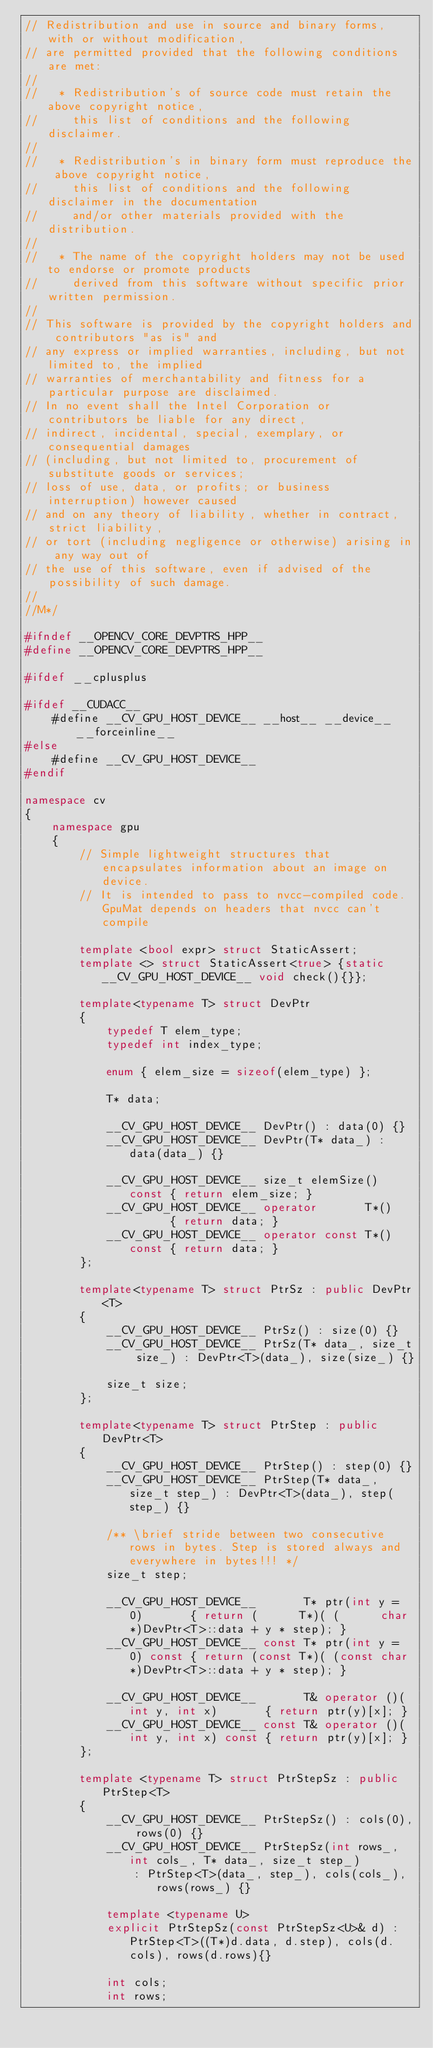<code> <loc_0><loc_0><loc_500><loc_500><_C++_>// Redistribution and use in source and binary forms, with or without modification,
// are permitted provided that the following conditions are met:
//
//   * Redistribution's of source code must retain the above copyright notice,
//     this list of conditions and the following disclaimer.
//
//   * Redistribution's in binary form must reproduce the above copyright notice,
//     this list of conditions and the following disclaimer in the documentation
//     and/or other materials provided with the distribution.
//
//   * The name of the copyright holders may not be used to endorse or promote products
//     derived from this software without specific prior written permission.
//
// This software is provided by the copyright holders and contributors "as is" and
// any express or implied warranties, including, but not limited to, the implied
// warranties of merchantability and fitness for a particular purpose are disclaimed.
// In no event shall the Intel Corporation or contributors be liable for any direct,
// indirect, incidental, special, exemplary, or consequential damages
// (including, but not limited to, procurement of substitute goods or services;
// loss of use, data, or profits; or business interruption) however caused
// and on any theory of liability, whether in contract, strict liability,
// or tort (including negligence or otherwise) arising in any way out of
// the use of this software, even if advised of the possibility of such damage.
//
//M*/

#ifndef __OPENCV_CORE_DEVPTRS_HPP__
#define __OPENCV_CORE_DEVPTRS_HPP__

#ifdef __cplusplus

#ifdef __CUDACC__
    #define __CV_GPU_HOST_DEVICE__ __host__ __device__ __forceinline__
#else
    #define __CV_GPU_HOST_DEVICE__
#endif

namespace cv
{
    namespace gpu
    {
        // Simple lightweight structures that encapsulates information about an image on device.
        // It is intended to pass to nvcc-compiled code. GpuMat depends on headers that nvcc can't compile

        template <bool expr> struct StaticAssert;
        template <> struct StaticAssert<true> {static __CV_GPU_HOST_DEVICE__ void check(){}};

        template<typename T> struct DevPtr
        {
            typedef T elem_type;
            typedef int index_type;

            enum { elem_size = sizeof(elem_type) };

            T* data;

            __CV_GPU_HOST_DEVICE__ DevPtr() : data(0) {}
            __CV_GPU_HOST_DEVICE__ DevPtr(T* data_) : data(data_) {}

            __CV_GPU_HOST_DEVICE__ size_t elemSize() const { return elem_size; }
            __CV_GPU_HOST_DEVICE__ operator       T*()       { return data; }
            __CV_GPU_HOST_DEVICE__ operator const T*() const { return data; }
        };

        template<typename T> struct PtrSz : public DevPtr<T>
        {
            __CV_GPU_HOST_DEVICE__ PtrSz() : size(0) {}
            __CV_GPU_HOST_DEVICE__ PtrSz(T* data_, size_t size_) : DevPtr<T>(data_), size(size_) {}

            size_t size;
        };

        template<typename T> struct PtrStep : public DevPtr<T>
        {
            __CV_GPU_HOST_DEVICE__ PtrStep() : step(0) {}
            __CV_GPU_HOST_DEVICE__ PtrStep(T* data_, size_t step_) : DevPtr<T>(data_), step(step_) {}

            /** \brief stride between two consecutive rows in bytes. Step is stored always and everywhere in bytes!!! */
            size_t step;

            __CV_GPU_HOST_DEVICE__       T* ptr(int y = 0)       { return (      T*)( (      char*)DevPtr<T>::data + y * step); }
            __CV_GPU_HOST_DEVICE__ const T* ptr(int y = 0) const { return (const T*)( (const char*)DevPtr<T>::data + y * step); }

            __CV_GPU_HOST_DEVICE__       T& operator ()(int y, int x)       { return ptr(y)[x]; }
            __CV_GPU_HOST_DEVICE__ const T& operator ()(int y, int x) const { return ptr(y)[x]; }
        };

        template <typename T> struct PtrStepSz : public PtrStep<T>
        {
            __CV_GPU_HOST_DEVICE__ PtrStepSz() : cols(0), rows(0) {}
            __CV_GPU_HOST_DEVICE__ PtrStepSz(int rows_, int cols_, T* data_, size_t step_)
                : PtrStep<T>(data_, step_), cols(cols_), rows(rows_) {}

            template <typename U>
            explicit PtrStepSz(const PtrStepSz<U>& d) : PtrStep<T>((T*)d.data, d.step), cols(d.cols), rows(d.rows){}

            int cols;
            int rows;</code> 